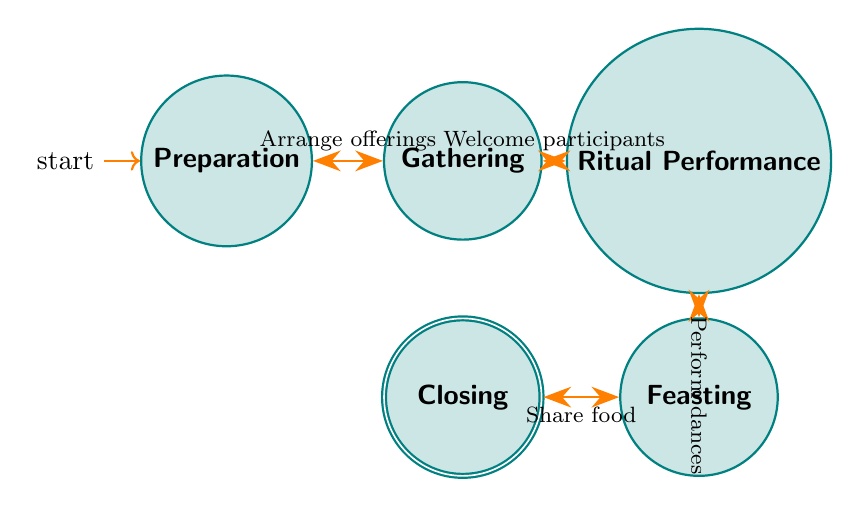What are the names of the states in this diagram? The diagram lists five states: Preparation, Gathering, Ritual Performance, Feasting, and Closing.
Answer: Preparation, Gathering, Ritual Performance, Feasting, Closing How many transitions are there in total? By counting the arrows in the diagram, there are four transitions that connect the states.
Answer: 4 What action occurs between Gathering and Ritual Performance? The action that links Gathering and Ritual Performance is "Welcome participants and set up the ritual space."
Answer: Welcome participants What is the final state reached after Feasting? From the diagram's flow, the final state that follows Feasting is Closing.
Answer: Closing What is the first action in the ritual process? The initial action in the process is "Arrange offerings and invite participants."
Answer: Arrange offerings What is the relationship between Ritual Performance and Feasting? The transition from Ritual Performance to Feasting requires the action "Perform traditional dances and prayers," establishing a direct flow between these two states.
Answer: Perform traditional dances What state directly follows Preparation? Immediately following Preparation in the diagram is the state Gathering.
Answer: Gathering Which state represents the conclusion of the ritual practices? The Closing state indicates the conclusion of the ritual practices.
Answer: Closing What is the action taken after Feasting? The action taken after Feasting is "Share food and stories among participants."
Answer: Share food 